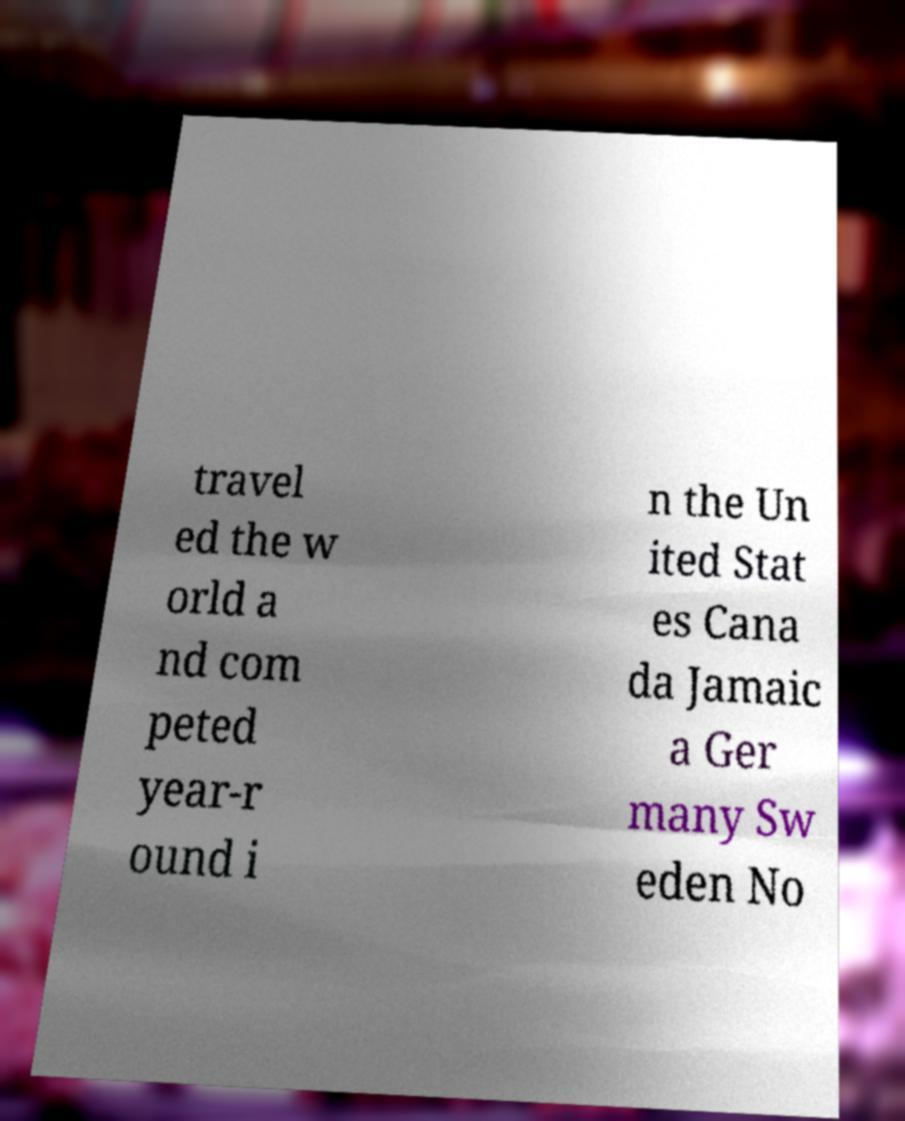Please identify and transcribe the text found in this image. travel ed the w orld a nd com peted year-r ound i n the Un ited Stat es Cana da Jamaic a Ger many Sw eden No 